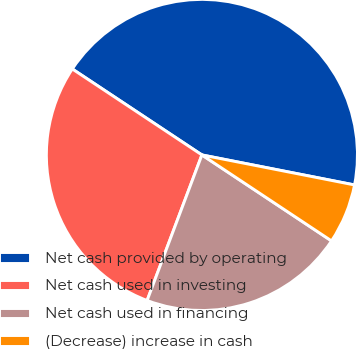<chart> <loc_0><loc_0><loc_500><loc_500><pie_chart><fcel>Net cash provided by operating<fcel>Net cash used in investing<fcel>Net cash used in financing<fcel>(Decrease) increase in cash<nl><fcel>43.77%<fcel>28.59%<fcel>21.41%<fcel>6.23%<nl></chart> 